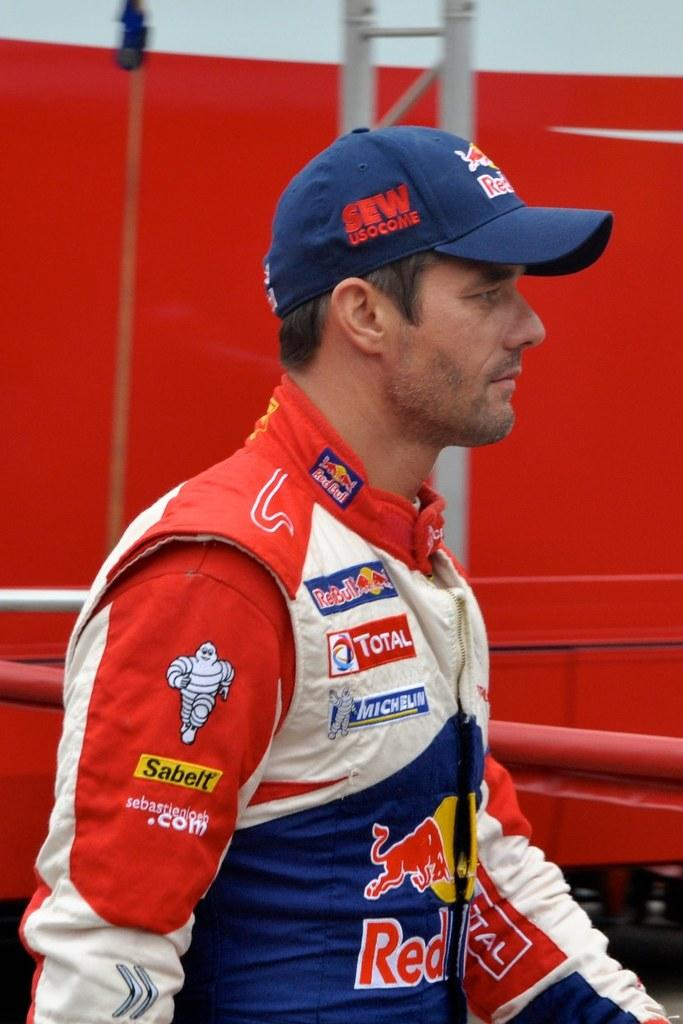<image>
Render a clear and concise summary of the photo. Logos from corporations such as Red Bull, Michelin festoon the driving suit of a car race 